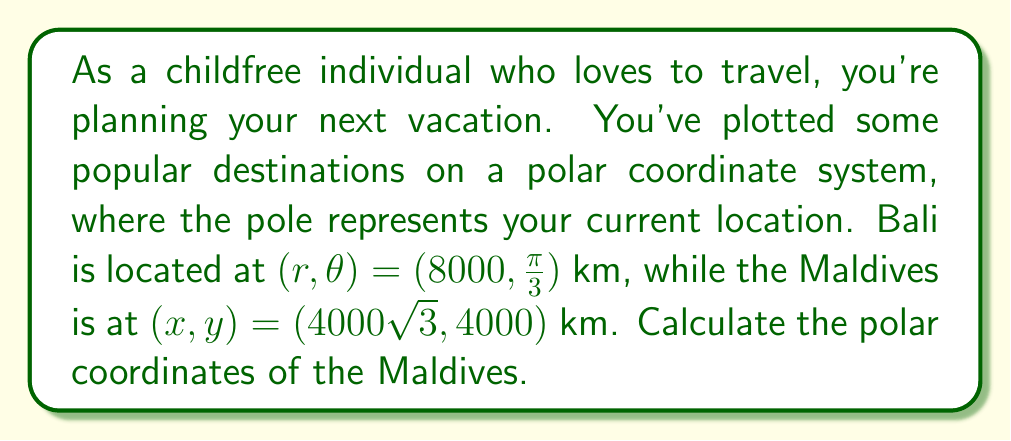Give your solution to this math problem. To solve this problem, we need to convert the Cartesian coordinates of the Maldives to polar coordinates. Let's approach this step-by-step:

1. Given:
   - Bali: $(r, \theta) = (8000, \frac{\pi}{3})$ km
   - Maldives: $(x, y) = (4000\sqrt{3}, 4000)$ km

2. To convert from Cartesian to polar coordinates, we use these formulas:
   $r = \sqrt{x^2 + y^2}$
   $\theta = \tan^{-1}(\frac{y}{x})$

3. Calculate $r$ for the Maldives:
   $r = \sqrt{(4000\sqrt{3})^2 + 4000^2}$
   $r = \sqrt{48,000,000 + 16,000,000}$
   $r = \sqrt{64,000,000}$
   $r = 8000$ km

4. Calculate $\theta$ for the Maldives:
   $\theta = \tan^{-1}(\frac{4000}{4000\sqrt{3}})$
   $\theta = \tan^{-1}(\frac{1}{\sqrt{3}})$
   $\theta = \frac{\pi}{6}$ radians

5. Therefore, the polar coordinates of the Maldives are $(8000, \frac{\pi}{6})$ km.

Note: This problem is relevant to the given persona as it focuses on vacation planning without mentioning family or children, aligning with the childfree lifestyle.
Answer: The polar coordinates of the Maldives are $(r, \theta) = (8000, \frac{\pi}{6})$ km. 